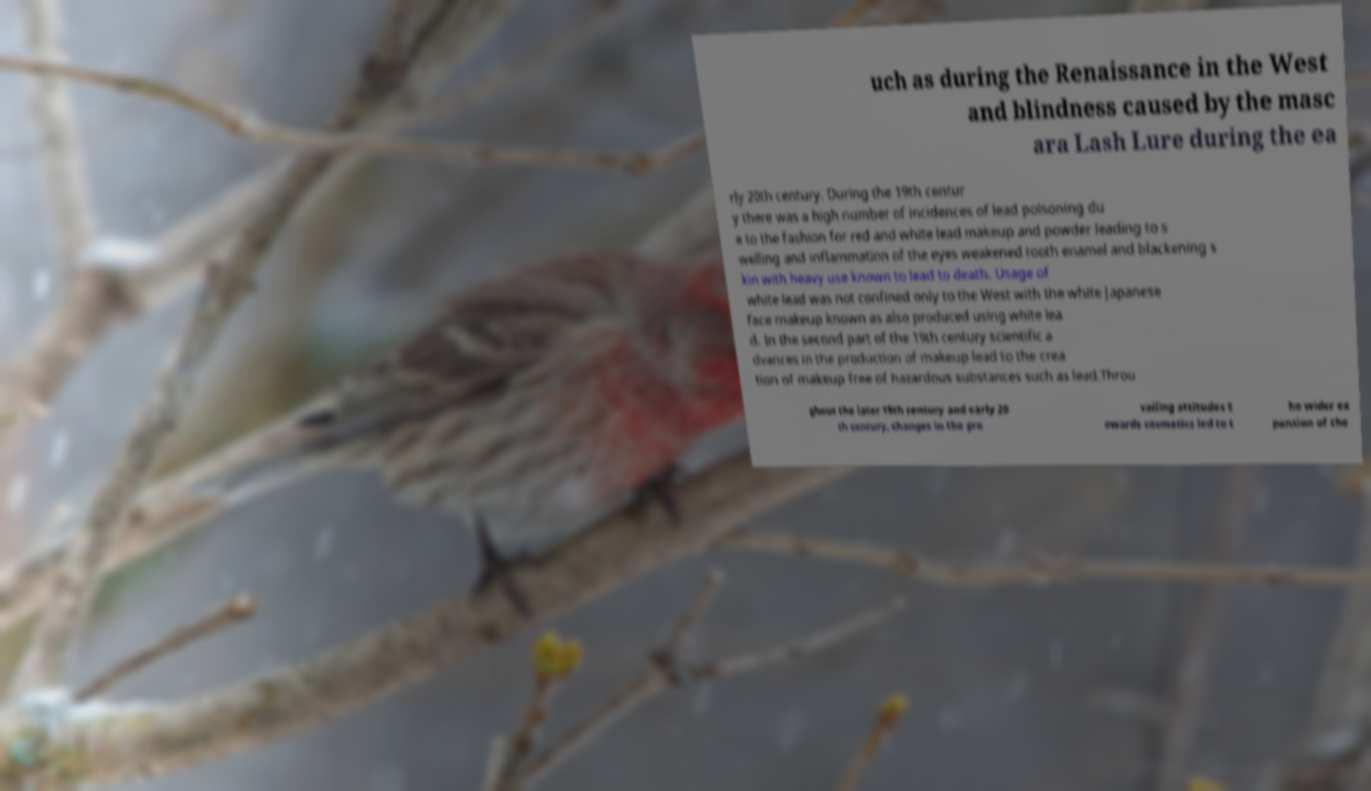Could you assist in decoding the text presented in this image and type it out clearly? uch as during the Renaissance in the West and blindness caused by the masc ara Lash Lure during the ea rly 20th century. During the 19th centur y there was a high number of incidences of lead poisoning du e to the fashion for red and white lead makeup and powder leading to s welling and inflammation of the eyes weakened tooth enamel and blackening s kin with heavy use known to lead to death. Usage of white lead was not confined only to the West with the white Japanese face makeup known as also produced using white lea d. In the second part of the 19th century scientific a dvances in the production of makeup lead to the crea tion of makeup free of hazardous substances such as lead.Throu ghout the later 19th century and early 20 th century, changes in the pre vailing attitudes t owards cosmetics led to t he wider ex pansion of the 